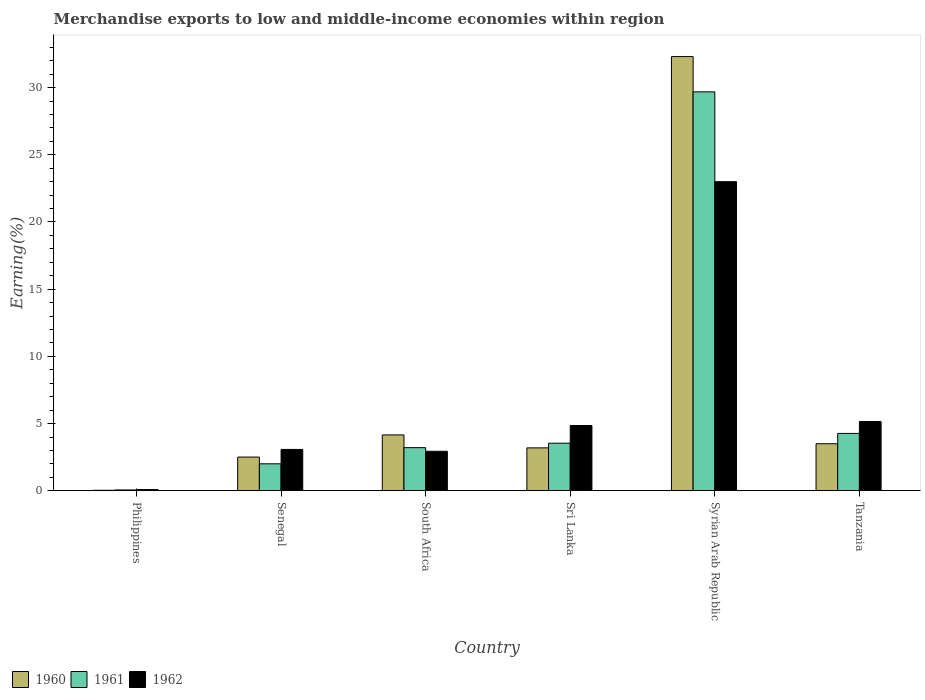How many different coloured bars are there?
Give a very brief answer. 3. How many groups of bars are there?
Offer a terse response. 6. Are the number of bars per tick equal to the number of legend labels?
Your response must be concise. Yes. How many bars are there on the 1st tick from the right?
Keep it short and to the point. 3. What is the label of the 5th group of bars from the left?
Your answer should be compact. Syrian Arab Republic. What is the percentage of amount earned from merchandise exports in 1961 in Tanzania?
Your response must be concise. 4.27. Across all countries, what is the maximum percentage of amount earned from merchandise exports in 1960?
Offer a terse response. 32.31. Across all countries, what is the minimum percentage of amount earned from merchandise exports in 1961?
Keep it short and to the point. 0.06. In which country was the percentage of amount earned from merchandise exports in 1960 maximum?
Give a very brief answer. Syrian Arab Republic. What is the total percentage of amount earned from merchandise exports in 1962 in the graph?
Make the answer very short. 39.12. What is the difference between the percentage of amount earned from merchandise exports in 1960 in Philippines and that in South Africa?
Your answer should be very brief. -4.12. What is the difference between the percentage of amount earned from merchandise exports in 1962 in Syrian Arab Republic and the percentage of amount earned from merchandise exports in 1960 in Senegal?
Your answer should be very brief. 20.49. What is the average percentage of amount earned from merchandise exports in 1960 per country?
Offer a terse response. 7.62. What is the difference between the percentage of amount earned from merchandise exports of/in 1962 and percentage of amount earned from merchandise exports of/in 1960 in Philippines?
Your answer should be very brief. 0.05. What is the ratio of the percentage of amount earned from merchandise exports in 1961 in Senegal to that in Tanzania?
Your response must be concise. 0.47. Is the percentage of amount earned from merchandise exports in 1962 in Senegal less than that in Tanzania?
Your answer should be compact. Yes. Is the difference between the percentage of amount earned from merchandise exports in 1962 in Senegal and Tanzania greater than the difference between the percentage of amount earned from merchandise exports in 1960 in Senegal and Tanzania?
Make the answer very short. No. What is the difference between the highest and the second highest percentage of amount earned from merchandise exports in 1961?
Keep it short and to the point. -0.73. What is the difference between the highest and the lowest percentage of amount earned from merchandise exports in 1960?
Ensure brevity in your answer.  32.27. In how many countries, is the percentage of amount earned from merchandise exports in 1960 greater than the average percentage of amount earned from merchandise exports in 1960 taken over all countries?
Provide a short and direct response. 1. Is the sum of the percentage of amount earned from merchandise exports in 1961 in Philippines and Tanzania greater than the maximum percentage of amount earned from merchandise exports in 1962 across all countries?
Keep it short and to the point. No. Is it the case that in every country, the sum of the percentage of amount earned from merchandise exports in 1960 and percentage of amount earned from merchandise exports in 1962 is greater than the percentage of amount earned from merchandise exports in 1961?
Ensure brevity in your answer.  Yes. Are all the bars in the graph horizontal?
Offer a terse response. No. How many countries are there in the graph?
Keep it short and to the point. 6. What is the difference between two consecutive major ticks on the Y-axis?
Provide a succinct answer. 5. Are the values on the major ticks of Y-axis written in scientific E-notation?
Your answer should be very brief. No. Does the graph contain any zero values?
Your answer should be very brief. No. Does the graph contain grids?
Offer a very short reply. No. Where does the legend appear in the graph?
Provide a short and direct response. Bottom left. How are the legend labels stacked?
Make the answer very short. Horizontal. What is the title of the graph?
Your answer should be very brief. Merchandise exports to low and middle-income economies within region. Does "2008" appear as one of the legend labels in the graph?
Offer a terse response. No. What is the label or title of the X-axis?
Keep it short and to the point. Country. What is the label or title of the Y-axis?
Your answer should be compact. Earning(%). What is the Earning(%) in 1960 in Philippines?
Keep it short and to the point. 0.04. What is the Earning(%) of 1961 in Philippines?
Provide a short and direct response. 0.06. What is the Earning(%) of 1962 in Philippines?
Offer a terse response. 0.09. What is the Earning(%) in 1960 in Senegal?
Provide a short and direct response. 2.51. What is the Earning(%) of 1961 in Senegal?
Provide a succinct answer. 2.01. What is the Earning(%) of 1962 in Senegal?
Make the answer very short. 3.08. What is the Earning(%) of 1960 in South Africa?
Give a very brief answer. 4.16. What is the Earning(%) in 1961 in South Africa?
Your answer should be very brief. 3.21. What is the Earning(%) in 1962 in South Africa?
Make the answer very short. 2.94. What is the Earning(%) of 1960 in Sri Lanka?
Keep it short and to the point. 3.19. What is the Earning(%) of 1961 in Sri Lanka?
Make the answer very short. 3.54. What is the Earning(%) of 1962 in Sri Lanka?
Ensure brevity in your answer.  4.86. What is the Earning(%) in 1960 in Syrian Arab Republic?
Provide a succinct answer. 32.31. What is the Earning(%) of 1961 in Syrian Arab Republic?
Offer a very short reply. 29.68. What is the Earning(%) in 1962 in Syrian Arab Republic?
Offer a very short reply. 23. What is the Earning(%) in 1960 in Tanzania?
Your response must be concise. 3.5. What is the Earning(%) in 1961 in Tanzania?
Provide a succinct answer. 4.27. What is the Earning(%) in 1962 in Tanzania?
Your response must be concise. 5.16. Across all countries, what is the maximum Earning(%) of 1960?
Offer a very short reply. 32.31. Across all countries, what is the maximum Earning(%) of 1961?
Make the answer very short. 29.68. Across all countries, what is the maximum Earning(%) in 1962?
Keep it short and to the point. 23. Across all countries, what is the minimum Earning(%) of 1960?
Your response must be concise. 0.04. Across all countries, what is the minimum Earning(%) in 1961?
Provide a short and direct response. 0.06. Across all countries, what is the minimum Earning(%) in 1962?
Offer a very short reply. 0.09. What is the total Earning(%) of 1960 in the graph?
Your answer should be very brief. 45.71. What is the total Earning(%) in 1961 in the graph?
Your response must be concise. 42.77. What is the total Earning(%) in 1962 in the graph?
Your answer should be compact. 39.12. What is the difference between the Earning(%) of 1960 in Philippines and that in Senegal?
Give a very brief answer. -2.47. What is the difference between the Earning(%) of 1961 in Philippines and that in Senegal?
Provide a succinct answer. -1.95. What is the difference between the Earning(%) of 1962 in Philippines and that in Senegal?
Provide a short and direct response. -2.99. What is the difference between the Earning(%) in 1960 in Philippines and that in South Africa?
Your response must be concise. -4.12. What is the difference between the Earning(%) of 1961 in Philippines and that in South Africa?
Offer a very short reply. -3.15. What is the difference between the Earning(%) in 1962 in Philippines and that in South Africa?
Your answer should be very brief. -2.85. What is the difference between the Earning(%) in 1960 in Philippines and that in Sri Lanka?
Keep it short and to the point. -3.16. What is the difference between the Earning(%) of 1961 in Philippines and that in Sri Lanka?
Offer a very short reply. -3.48. What is the difference between the Earning(%) in 1962 in Philippines and that in Sri Lanka?
Your answer should be compact. -4.77. What is the difference between the Earning(%) in 1960 in Philippines and that in Syrian Arab Republic?
Offer a terse response. -32.27. What is the difference between the Earning(%) of 1961 in Philippines and that in Syrian Arab Republic?
Your answer should be very brief. -29.62. What is the difference between the Earning(%) of 1962 in Philippines and that in Syrian Arab Republic?
Your answer should be very brief. -22.91. What is the difference between the Earning(%) of 1960 in Philippines and that in Tanzania?
Your answer should be very brief. -3.46. What is the difference between the Earning(%) of 1961 in Philippines and that in Tanzania?
Provide a short and direct response. -4.21. What is the difference between the Earning(%) of 1962 in Philippines and that in Tanzania?
Ensure brevity in your answer.  -5.07. What is the difference between the Earning(%) of 1960 in Senegal and that in South Africa?
Provide a short and direct response. -1.65. What is the difference between the Earning(%) in 1961 in Senegal and that in South Africa?
Your response must be concise. -1.2. What is the difference between the Earning(%) in 1962 in Senegal and that in South Africa?
Offer a terse response. 0.14. What is the difference between the Earning(%) of 1960 in Senegal and that in Sri Lanka?
Make the answer very short. -0.68. What is the difference between the Earning(%) of 1961 in Senegal and that in Sri Lanka?
Give a very brief answer. -1.53. What is the difference between the Earning(%) of 1962 in Senegal and that in Sri Lanka?
Give a very brief answer. -1.78. What is the difference between the Earning(%) in 1960 in Senegal and that in Syrian Arab Republic?
Ensure brevity in your answer.  -29.8. What is the difference between the Earning(%) in 1961 in Senegal and that in Syrian Arab Republic?
Keep it short and to the point. -27.68. What is the difference between the Earning(%) in 1962 in Senegal and that in Syrian Arab Republic?
Keep it short and to the point. -19.92. What is the difference between the Earning(%) of 1960 in Senegal and that in Tanzania?
Offer a very short reply. -0.99. What is the difference between the Earning(%) of 1961 in Senegal and that in Tanzania?
Give a very brief answer. -2.26. What is the difference between the Earning(%) in 1962 in Senegal and that in Tanzania?
Offer a terse response. -2.08. What is the difference between the Earning(%) in 1960 in South Africa and that in Sri Lanka?
Offer a terse response. 0.96. What is the difference between the Earning(%) in 1961 in South Africa and that in Sri Lanka?
Keep it short and to the point. -0.33. What is the difference between the Earning(%) of 1962 in South Africa and that in Sri Lanka?
Keep it short and to the point. -1.92. What is the difference between the Earning(%) of 1960 in South Africa and that in Syrian Arab Republic?
Provide a short and direct response. -28.15. What is the difference between the Earning(%) in 1961 in South Africa and that in Syrian Arab Republic?
Your answer should be very brief. -26.47. What is the difference between the Earning(%) in 1962 in South Africa and that in Syrian Arab Republic?
Offer a very short reply. -20.06. What is the difference between the Earning(%) of 1960 in South Africa and that in Tanzania?
Give a very brief answer. 0.66. What is the difference between the Earning(%) in 1961 in South Africa and that in Tanzania?
Provide a succinct answer. -1.06. What is the difference between the Earning(%) in 1962 in South Africa and that in Tanzania?
Offer a terse response. -2.22. What is the difference between the Earning(%) of 1960 in Sri Lanka and that in Syrian Arab Republic?
Your response must be concise. -29.11. What is the difference between the Earning(%) in 1961 in Sri Lanka and that in Syrian Arab Republic?
Offer a very short reply. -26.14. What is the difference between the Earning(%) in 1962 in Sri Lanka and that in Syrian Arab Republic?
Provide a succinct answer. -18.14. What is the difference between the Earning(%) of 1960 in Sri Lanka and that in Tanzania?
Give a very brief answer. -0.31. What is the difference between the Earning(%) in 1961 in Sri Lanka and that in Tanzania?
Keep it short and to the point. -0.73. What is the difference between the Earning(%) in 1962 in Sri Lanka and that in Tanzania?
Provide a succinct answer. -0.3. What is the difference between the Earning(%) in 1960 in Syrian Arab Republic and that in Tanzania?
Ensure brevity in your answer.  28.81. What is the difference between the Earning(%) of 1961 in Syrian Arab Republic and that in Tanzania?
Ensure brevity in your answer.  25.41. What is the difference between the Earning(%) of 1962 in Syrian Arab Republic and that in Tanzania?
Your response must be concise. 17.84. What is the difference between the Earning(%) in 1960 in Philippines and the Earning(%) in 1961 in Senegal?
Make the answer very short. -1.97. What is the difference between the Earning(%) in 1960 in Philippines and the Earning(%) in 1962 in Senegal?
Give a very brief answer. -3.04. What is the difference between the Earning(%) of 1961 in Philippines and the Earning(%) of 1962 in Senegal?
Your answer should be very brief. -3.02. What is the difference between the Earning(%) of 1960 in Philippines and the Earning(%) of 1961 in South Africa?
Make the answer very short. -3.17. What is the difference between the Earning(%) of 1960 in Philippines and the Earning(%) of 1962 in South Africa?
Ensure brevity in your answer.  -2.9. What is the difference between the Earning(%) in 1961 in Philippines and the Earning(%) in 1962 in South Africa?
Provide a succinct answer. -2.88. What is the difference between the Earning(%) in 1960 in Philippines and the Earning(%) in 1961 in Sri Lanka?
Your answer should be compact. -3.5. What is the difference between the Earning(%) in 1960 in Philippines and the Earning(%) in 1962 in Sri Lanka?
Offer a terse response. -4.82. What is the difference between the Earning(%) in 1961 in Philippines and the Earning(%) in 1962 in Sri Lanka?
Provide a short and direct response. -4.8. What is the difference between the Earning(%) of 1960 in Philippines and the Earning(%) of 1961 in Syrian Arab Republic?
Offer a terse response. -29.65. What is the difference between the Earning(%) in 1960 in Philippines and the Earning(%) in 1962 in Syrian Arab Republic?
Provide a succinct answer. -22.96. What is the difference between the Earning(%) in 1961 in Philippines and the Earning(%) in 1962 in Syrian Arab Republic?
Your answer should be very brief. -22.94. What is the difference between the Earning(%) of 1960 in Philippines and the Earning(%) of 1961 in Tanzania?
Give a very brief answer. -4.23. What is the difference between the Earning(%) in 1960 in Philippines and the Earning(%) in 1962 in Tanzania?
Keep it short and to the point. -5.12. What is the difference between the Earning(%) of 1961 in Philippines and the Earning(%) of 1962 in Tanzania?
Your answer should be very brief. -5.09. What is the difference between the Earning(%) of 1960 in Senegal and the Earning(%) of 1961 in South Africa?
Give a very brief answer. -0.7. What is the difference between the Earning(%) of 1960 in Senegal and the Earning(%) of 1962 in South Africa?
Make the answer very short. -0.43. What is the difference between the Earning(%) in 1961 in Senegal and the Earning(%) in 1962 in South Africa?
Make the answer very short. -0.93. What is the difference between the Earning(%) of 1960 in Senegal and the Earning(%) of 1961 in Sri Lanka?
Make the answer very short. -1.03. What is the difference between the Earning(%) of 1960 in Senegal and the Earning(%) of 1962 in Sri Lanka?
Make the answer very short. -2.35. What is the difference between the Earning(%) of 1961 in Senegal and the Earning(%) of 1962 in Sri Lanka?
Your answer should be very brief. -2.85. What is the difference between the Earning(%) in 1960 in Senegal and the Earning(%) in 1961 in Syrian Arab Republic?
Your response must be concise. -27.17. What is the difference between the Earning(%) in 1960 in Senegal and the Earning(%) in 1962 in Syrian Arab Republic?
Make the answer very short. -20.49. What is the difference between the Earning(%) in 1961 in Senegal and the Earning(%) in 1962 in Syrian Arab Republic?
Your answer should be very brief. -20.99. What is the difference between the Earning(%) of 1960 in Senegal and the Earning(%) of 1961 in Tanzania?
Provide a short and direct response. -1.76. What is the difference between the Earning(%) of 1960 in Senegal and the Earning(%) of 1962 in Tanzania?
Keep it short and to the point. -2.65. What is the difference between the Earning(%) of 1961 in Senegal and the Earning(%) of 1962 in Tanzania?
Offer a very short reply. -3.15. What is the difference between the Earning(%) in 1960 in South Africa and the Earning(%) in 1961 in Sri Lanka?
Provide a succinct answer. 0.62. What is the difference between the Earning(%) in 1960 in South Africa and the Earning(%) in 1962 in Sri Lanka?
Offer a very short reply. -0.7. What is the difference between the Earning(%) in 1961 in South Africa and the Earning(%) in 1962 in Sri Lanka?
Give a very brief answer. -1.65. What is the difference between the Earning(%) in 1960 in South Africa and the Earning(%) in 1961 in Syrian Arab Republic?
Make the answer very short. -25.53. What is the difference between the Earning(%) of 1960 in South Africa and the Earning(%) of 1962 in Syrian Arab Republic?
Make the answer very short. -18.84. What is the difference between the Earning(%) of 1961 in South Africa and the Earning(%) of 1962 in Syrian Arab Republic?
Your response must be concise. -19.79. What is the difference between the Earning(%) in 1960 in South Africa and the Earning(%) in 1961 in Tanzania?
Offer a terse response. -0.11. What is the difference between the Earning(%) of 1960 in South Africa and the Earning(%) of 1962 in Tanzania?
Your answer should be very brief. -1. What is the difference between the Earning(%) of 1961 in South Africa and the Earning(%) of 1962 in Tanzania?
Provide a succinct answer. -1.95. What is the difference between the Earning(%) in 1960 in Sri Lanka and the Earning(%) in 1961 in Syrian Arab Republic?
Your answer should be very brief. -26.49. What is the difference between the Earning(%) of 1960 in Sri Lanka and the Earning(%) of 1962 in Syrian Arab Republic?
Offer a very short reply. -19.8. What is the difference between the Earning(%) in 1961 in Sri Lanka and the Earning(%) in 1962 in Syrian Arab Republic?
Provide a short and direct response. -19.46. What is the difference between the Earning(%) of 1960 in Sri Lanka and the Earning(%) of 1961 in Tanzania?
Provide a short and direct response. -1.08. What is the difference between the Earning(%) of 1960 in Sri Lanka and the Earning(%) of 1962 in Tanzania?
Your answer should be compact. -1.96. What is the difference between the Earning(%) of 1961 in Sri Lanka and the Earning(%) of 1962 in Tanzania?
Your response must be concise. -1.61. What is the difference between the Earning(%) of 1960 in Syrian Arab Republic and the Earning(%) of 1961 in Tanzania?
Your answer should be compact. 28.04. What is the difference between the Earning(%) in 1960 in Syrian Arab Republic and the Earning(%) in 1962 in Tanzania?
Ensure brevity in your answer.  27.15. What is the difference between the Earning(%) of 1961 in Syrian Arab Republic and the Earning(%) of 1962 in Tanzania?
Ensure brevity in your answer.  24.53. What is the average Earning(%) of 1960 per country?
Offer a very short reply. 7.62. What is the average Earning(%) of 1961 per country?
Your answer should be very brief. 7.13. What is the average Earning(%) of 1962 per country?
Your answer should be very brief. 6.52. What is the difference between the Earning(%) of 1960 and Earning(%) of 1961 in Philippines?
Offer a very short reply. -0.02. What is the difference between the Earning(%) of 1960 and Earning(%) of 1962 in Philippines?
Give a very brief answer. -0.05. What is the difference between the Earning(%) of 1961 and Earning(%) of 1962 in Philippines?
Offer a very short reply. -0.03. What is the difference between the Earning(%) of 1960 and Earning(%) of 1961 in Senegal?
Offer a very short reply. 0.5. What is the difference between the Earning(%) of 1960 and Earning(%) of 1962 in Senegal?
Ensure brevity in your answer.  -0.57. What is the difference between the Earning(%) in 1961 and Earning(%) in 1962 in Senegal?
Provide a succinct answer. -1.07. What is the difference between the Earning(%) in 1960 and Earning(%) in 1961 in South Africa?
Your response must be concise. 0.95. What is the difference between the Earning(%) of 1960 and Earning(%) of 1962 in South Africa?
Provide a succinct answer. 1.22. What is the difference between the Earning(%) of 1961 and Earning(%) of 1962 in South Africa?
Provide a succinct answer. 0.27. What is the difference between the Earning(%) of 1960 and Earning(%) of 1961 in Sri Lanka?
Offer a very short reply. -0.35. What is the difference between the Earning(%) in 1960 and Earning(%) in 1962 in Sri Lanka?
Offer a very short reply. -1.66. What is the difference between the Earning(%) in 1961 and Earning(%) in 1962 in Sri Lanka?
Make the answer very short. -1.32. What is the difference between the Earning(%) in 1960 and Earning(%) in 1961 in Syrian Arab Republic?
Offer a terse response. 2.62. What is the difference between the Earning(%) in 1960 and Earning(%) in 1962 in Syrian Arab Republic?
Provide a short and direct response. 9.31. What is the difference between the Earning(%) in 1961 and Earning(%) in 1962 in Syrian Arab Republic?
Ensure brevity in your answer.  6.68. What is the difference between the Earning(%) of 1960 and Earning(%) of 1961 in Tanzania?
Make the answer very short. -0.77. What is the difference between the Earning(%) in 1960 and Earning(%) in 1962 in Tanzania?
Your answer should be compact. -1.65. What is the difference between the Earning(%) in 1961 and Earning(%) in 1962 in Tanzania?
Provide a short and direct response. -0.89. What is the ratio of the Earning(%) of 1960 in Philippines to that in Senegal?
Make the answer very short. 0.01. What is the ratio of the Earning(%) of 1961 in Philippines to that in Senegal?
Keep it short and to the point. 0.03. What is the ratio of the Earning(%) in 1962 in Philippines to that in Senegal?
Provide a succinct answer. 0.03. What is the ratio of the Earning(%) of 1960 in Philippines to that in South Africa?
Your answer should be very brief. 0.01. What is the ratio of the Earning(%) of 1961 in Philippines to that in South Africa?
Give a very brief answer. 0.02. What is the ratio of the Earning(%) in 1962 in Philippines to that in South Africa?
Provide a succinct answer. 0.03. What is the ratio of the Earning(%) of 1960 in Philippines to that in Sri Lanka?
Give a very brief answer. 0.01. What is the ratio of the Earning(%) of 1961 in Philippines to that in Sri Lanka?
Your answer should be very brief. 0.02. What is the ratio of the Earning(%) of 1962 in Philippines to that in Sri Lanka?
Give a very brief answer. 0.02. What is the ratio of the Earning(%) in 1960 in Philippines to that in Syrian Arab Republic?
Keep it short and to the point. 0. What is the ratio of the Earning(%) in 1961 in Philippines to that in Syrian Arab Republic?
Your answer should be very brief. 0. What is the ratio of the Earning(%) of 1962 in Philippines to that in Syrian Arab Republic?
Offer a terse response. 0. What is the ratio of the Earning(%) in 1960 in Philippines to that in Tanzania?
Offer a terse response. 0.01. What is the ratio of the Earning(%) in 1961 in Philippines to that in Tanzania?
Provide a succinct answer. 0.01. What is the ratio of the Earning(%) in 1962 in Philippines to that in Tanzania?
Offer a terse response. 0.02. What is the ratio of the Earning(%) in 1960 in Senegal to that in South Africa?
Your answer should be compact. 0.6. What is the ratio of the Earning(%) of 1961 in Senegal to that in South Africa?
Offer a terse response. 0.63. What is the ratio of the Earning(%) of 1962 in Senegal to that in South Africa?
Keep it short and to the point. 1.05. What is the ratio of the Earning(%) of 1960 in Senegal to that in Sri Lanka?
Your response must be concise. 0.79. What is the ratio of the Earning(%) of 1961 in Senegal to that in Sri Lanka?
Provide a succinct answer. 0.57. What is the ratio of the Earning(%) in 1962 in Senegal to that in Sri Lanka?
Keep it short and to the point. 0.63. What is the ratio of the Earning(%) of 1960 in Senegal to that in Syrian Arab Republic?
Give a very brief answer. 0.08. What is the ratio of the Earning(%) of 1961 in Senegal to that in Syrian Arab Republic?
Ensure brevity in your answer.  0.07. What is the ratio of the Earning(%) in 1962 in Senegal to that in Syrian Arab Republic?
Your answer should be very brief. 0.13. What is the ratio of the Earning(%) of 1960 in Senegal to that in Tanzania?
Provide a succinct answer. 0.72. What is the ratio of the Earning(%) in 1961 in Senegal to that in Tanzania?
Provide a succinct answer. 0.47. What is the ratio of the Earning(%) of 1962 in Senegal to that in Tanzania?
Your answer should be compact. 0.6. What is the ratio of the Earning(%) in 1960 in South Africa to that in Sri Lanka?
Provide a short and direct response. 1.3. What is the ratio of the Earning(%) of 1961 in South Africa to that in Sri Lanka?
Your response must be concise. 0.91. What is the ratio of the Earning(%) of 1962 in South Africa to that in Sri Lanka?
Your response must be concise. 0.6. What is the ratio of the Earning(%) of 1960 in South Africa to that in Syrian Arab Republic?
Ensure brevity in your answer.  0.13. What is the ratio of the Earning(%) of 1961 in South Africa to that in Syrian Arab Republic?
Your answer should be very brief. 0.11. What is the ratio of the Earning(%) of 1962 in South Africa to that in Syrian Arab Republic?
Give a very brief answer. 0.13. What is the ratio of the Earning(%) of 1960 in South Africa to that in Tanzania?
Your answer should be compact. 1.19. What is the ratio of the Earning(%) of 1961 in South Africa to that in Tanzania?
Offer a very short reply. 0.75. What is the ratio of the Earning(%) in 1962 in South Africa to that in Tanzania?
Provide a succinct answer. 0.57. What is the ratio of the Earning(%) in 1960 in Sri Lanka to that in Syrian Arab Republic?
Make the answer very short. 0.1. What is the ratio of the Earning(%) of 1961 in Sri Lanka to that in Syrian Arab Republic?
Keep it short and to the point. 0.12. What is the ratio of the Earning(%) in 1962 in Sri Lanka to that in Syrian Arab Republic?
Keep it short and to the point. 0.21. What is the ratio of the Earning(%) of 1960 in Sri Lanka to that in Tanzania?
Give a very brief answer. 0.91. What is the ratio of the Earning(%) of 1961 in Sri Lanka to that in Tanzania?
Ensure brevity in your answer.  0.83. What is the ratio of the Earning(%) in 1962 in Sri Lanka to that in Tanzania?
Offer a terse response. 0.94. What is the ratio of the Earning(%) in 1960 in Syrian Arab Republic to that in Tanzania?
Give a very brief answer. 9.23. What is the ratio of the Earning(%) in 1961 in Syrian Arab Republic to that in Tanzania?
Make the answer very short. 6.95. What is the ratio of the Earning(%) of 1962 in Syrian Arab Republic to that in Tanzania?
Your answer should be very brief. 4.46. What is the difference between the highest and the second highest Earning(%) of 1960?
Offer a terse response. 28.15. What is the difference between the highest and the second highest Earning(%) of 1961?
Offer a very short reply. 25.41. What is the difference between the highest and the second highest Earning(%) of 1962?
Offer a very short reply. 17.84. What is the difference between the highest and the lowest Earning(%) in 1960?
Offer a very short reply. 32.27. What is the difference between the highest and the lowest Earning(%) in 1961?
Offer a very short reply. 29.62. What is the difference between the highest and the lowest Earning(%) of 1962?
Provide a short and direct response. 22.91. 